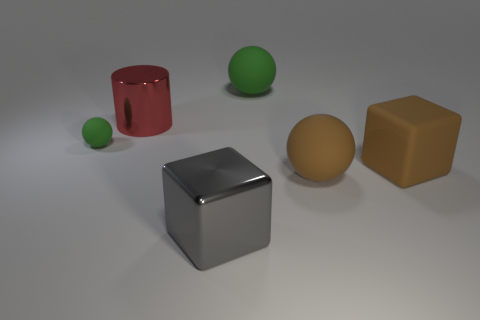Is the number of small spheres that are in front of the brown block greater than the number of large gray objects?
Provide a succinct answer. No. What size is the brown cube that is made of the same material as the large green object?
Keep it short and to the point. Large. Are there any green spheres on the right side of the red metal cylinder?
Ensure brevity in your answer.  Yes. Is the shape of the gray object the same as the big green matte thing?
Offer a terse response. No. How big is the green rubber object that is to the left of the large ball behind the green ball that is on the left side of the big green ball?
Provide a succinct answer. Small. What is the material of the large brown block?
Keep it short and to the point. Rubber. There is a ball that is the same color as the tiny thing; what is its size?
Your response must be concise. Large. Is the shape of the gray metallic thing the same as the green thing that is right of the tiny object?
Give a very brief answer. No. What material is the big object that is to the right of the rubber ball that is on the right side of the green thing on the right side of the big red object?
Your answer should be compact. Rubber. How many red metal cylinders are there?
Provide a succinct answer. 1. 